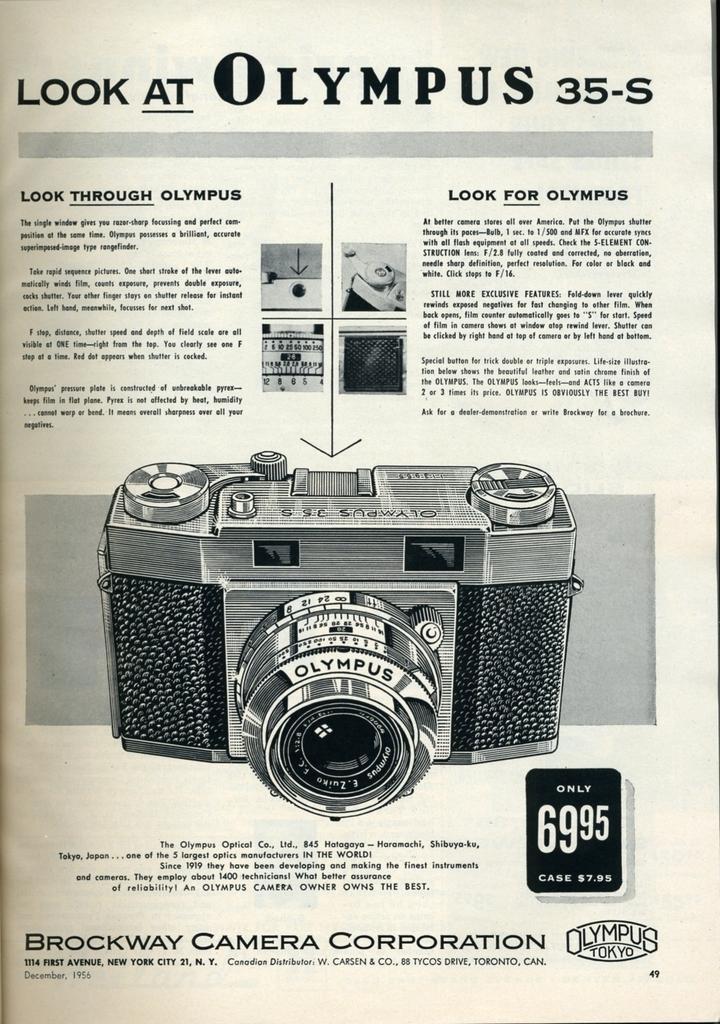Can you describe this image briefly? This is a paper. In the center of the image we can see a camera. In the background of the image we can see some text. 